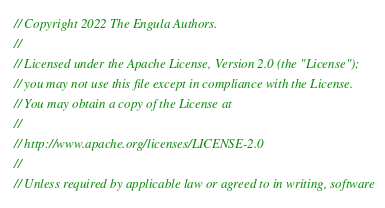<code> <loc_0><loc_0><loc_500><loc_500><_Rust_>// Copyright 2022 The Engula Authors.
//
// Licensed under the Apache License, Version 2.0 (the "License");
// you may not use this file except in compliance with the License.
// You may obtain a copy of the License at
//
// http://www.apache.org/licenses/LICENSE-2.0
//
// Unless required by applicable law or agreed to in writing, software</code> 